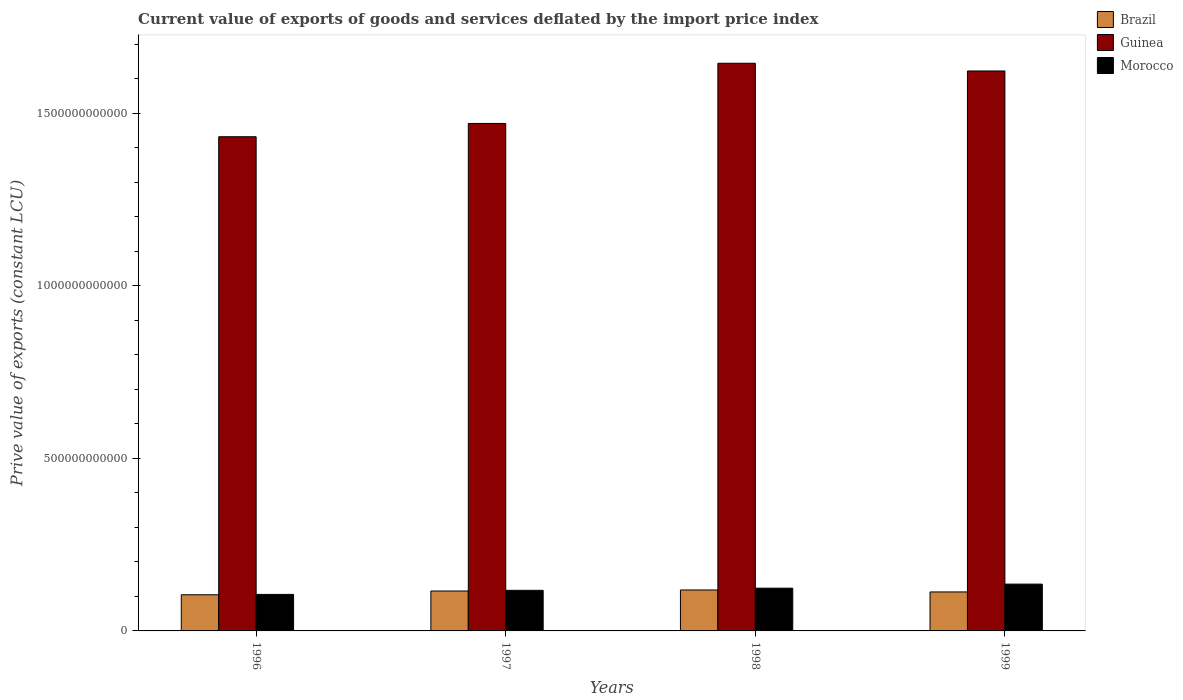How many different coloured bars are there?
Provide a succinct answer. 3. How many groups of bars are there?
Make the answer very short. 4. Are the number of bars per tick equal to the number of legend labels?
Provide a short and direct response. Yes. Are the number of bars on each tick of the X-axis equal?
Make the answer very short. Yes. How many bars are there on the 1st tick from the left?
Your answer should be compact. 3. How many bars are there on the 1st tick from the right?
Provide a short and direct response. 3. What is the prive value of exports in Brazil in 1998?
Your answer should be compact. 1.19e+11. Across all years, what is the maximum prive value of exports in Morocco?
Offer a terse response. 1.36e+11. Across all years, what is the minimum prive value of exports in Brazil?
Ensure brevity in your answer.  1.05e+11. In which year was the prive value of exports in Morocco maximum?
Make the answer very short. 1999. What is the total prive value of exports in Brazil in the graph?
Your response must be concise. 4.52e+11. What is the difference between the prive value of exports in Morocco in 1997 and that in 1999?
Keep it short and to the point. -1.80e+1. What is the difference between the prive value of exports in Morocco in 1998 and the prive value of exports in Brazil in 1999?
Your answer should be very brief. 1.09e+1. What is the average prive value of exports in Morocco per year?
Keep it short and to the point. 1.21e+11. In the year 1997, what is the difference between the prive value of exports in Guinea and prive value of exports in Morocco?
Keep it short and to the point. 1.35e+12. What is the ratio of the prive value of exports in Brazil in 1997 to that in 1999?
Offer a very short reply. 1.02. What is the difference between the highest and the second highest prive value of exports in Brazil?
Offer a terse response. 2.99e+09. What is the difference between the highest and the lowest prive value of exports in Brazil?
Your answer should be compact. 1.39e+1. In how many years, is the prive value of exports in Brazil greater than the average prive value of exports in Brazil taken over all years?
Provide a succinct answer. 2. What does the 3rd bar from the left in 1996 represents?
Offer a terse response. Morocco. What does the 1st bar from the right in 1997 represents?
Provide a succinct answer. Morocco. What is the difference between two consecutive major ticks on the Y-axis?
Provide a short and direct response. 5.00e+11. Are the values on the major ticks of Y-axis written in scientific E-notation?
Your answer should be very brief. No. Does the graph contain grids?
Offer a very short reply. No. Where does the legend appear in the graph?
Provide a succinct answer. Top right. What is the title of the graph?
Provide a short and direct response. Current value of exports of goods and services deflated by the import price index. What is the label or title of the Y-axis?
Your answer should be compact. Prive value of exports (constant LCU). What is the Prive value of exports (constant LCU) of Brazil in 1996?
Make the answer very short. 1.05e+11. What is the Prive value of exports (constant LCU) of Guinea in 1996?
Make the answer very short. 1.43e+12. What is the Prive value of exports (constant LCU) of Morocco in 1996?
Your answer should be compact. 1.06e+11. What is the Prive value of exports (constant LCU) of Brazil in 1997?
Offer a very short reply. 1.16e+11. What is the Prive value of exports (constant LCU) in Guinea in 1997?
Your response must be concise. 1.47e+12. What is the Prive value of exports (constant LCU) in Morocco in 1997?
Your response must be concise. 1.18e+11. What is the Prive value of exports (constant LCU) of Brazil in 1998?
Your answer should be compact. 1.19e+11. What is the Prive value of exports (constant LCU) of Guinea in 1998?
Offer a terse response. 1.64e+12. What is the Prive value of exports (constant LCU) of Morocco in 1998?
Your response must be concise. 1.24e+11. What is the Prive value of exports (constant LCU) in Brazil in 1999?
Offer a terse response. 1.13e+11. What is the Prive value of exports (constant LCU) of Guinea in 1999?
Offer a very short reply. 1.62e+12. What is the Prive value of exports (constant LCU) in Morocco in 1999?
Make the answer very short. 1.36e+11. Across all years, what is the maximum Prive value of exports (constant LCU) in Brazil?
Make the answer very short. 1.19e+11. Across all years, what is the maximum Prive value of exports (constant LCU) in Guinea?
Your answer should be very brief. 1.64e+12. Across all years, what is the maximum Prive value of exports (constant LCU) in Morocco?
Keep it short and to the point. 1.36e+11. Across all years, what is the minimum Prive value of exports (constant LCU) of Brazil?
Your response must be concise. 1.05e+11. Across all years, what is the minimum Prive value of exports (constant LCU) of Guinea?
Your answer should be compact. 1.43e+12. Across all years, what is the minimum Prive value of exports (constant LCU) of Morocco?
Your answer should be very brief. 1.06e+11. What is the total Prive value of exports (constant LCU) in Brazil in the graph?
Make the answer very short. 4.52e+11. What is the total Prive value of exports (constant LCU) of Guinea in the graph?
Provide a short and direct response. 6.17e+12. What is the total Prive value of exports (constant LCU) of Morocco in the graph?
Your response must be concise. 4.83e+11. What is the difference between the Prive value of exports (constant LCU) of Brazil in 1996 and that in 1997?
Your answer should be very brief. -1.09e+1. What is the difference between the Prive value of exports (constant LCU) of Guinea in 1996 and that in 1997?
Ensure brevity in your answer.  -3.85e+1. What is the difference between the Prive value of exports (constant LCU) of Morocco in 1996 and that in 1997?
Give a very brief answer. -1.18e+1. What is the difference between the Prive value of exports (constant LCU) of Brazil in 1996 and that in 1998?
Keep it short and to the point. -1.39e+1. What is the difference between the Prive value of exports (constant LCU) of Guinea in 1996 and that in 1998?
Your answer should be compact. -2.13e+11. What is the difference between the Prive value of exports (constant LCU) in Morocco in 1996 and that in 1998?
Your response must be concise. -1.80e+1. What is the difference between the Prive value of exports (constant LCU) of Brazil in 1996 and that in 1999?
Offer a terse response. -8.17e+09. What is the difference between the Prive value of exports (constant LCU) in Guinea in 1996 and that in 1999?
Provide a short and direct response. -1.91e+11. What is the difference between the Prive value of exports (constant LCU) in Morocco in 1996 and that in 1999?
Give a very brief answer. -2.98e+1. What is the difference between the Prive value of exports (constant LCU) of Brazil in 1997 and that in 1998?
Your response must be concise. -2.99e+09. What is the difference between the Prive value of exports (constant LCU) of Guinea in 1997 and that in 1998?
Give a very brief answer. -1.74e+11. What is the difference between the Prive value of exports (constant LCU) of Morocco in 1997 and that in 1998?
Give a very brief answer. -6.26e+09. What is the difference between the Prive value of exports (constant LCU) of Brazil in 1997 and that in 1999?
Offer a terse response. 2.72e+09. What is the difference between the Prive value of exports (constant LCU) in Guinea in 1997 and that in 1999?
Your response must be concise. -1.52e+11. What is the difference between the Prive value of exports (constant LCU) in Morocco in 1997 and that in 1999?
Ensure brevity in your answer.  -1.80e+1. What is the difference between the Prive value of exports (constant LCU) of Brazil in 1998 and that in 1999?
Provide a short and direct response. 5.71e+09. What is the difference between the Prive value of exports (constant LCU) of Guinea in 1998 and that in 1999?
Keep it short and to the point. 2.23e+1. What is the difference between the Prive value of exports (constant LCU) in Morocco in 1998 and that in 1999?
Ensure brevity in your answer.  -1.17e+1. What is the difference between the Prive value of exports (constant LCU) of Brazil in 1996 and the Prive value of exports (constant LCU) of Guinea in 1997?
Your answer should be compact. -1.37e+12. What is the difference between the Prive value of exports (constant LCU) of Brazil in 1996 and the Prive value of exports (constant LCU) of Morocco in 1997?
Your answer should be very brief. -1.28e+1. What is the difference between the Prive value of exports (constant LCU) of Guinea in 1996 and the Prive value of exports (constant LCU) of Morocco in 1997?
Your answer should be compact. 1.31e+12. What is the difference between the Prive value of exports (constant LCU) of Brazil in 1996 and the Prive value of exports (constant LCU) of Guinea in 1998?
Offer a very short reply. -1.54e+12. What is the difference between the Prive value of exports (constant LCU) of Brazil in 1996 and the Prive value of exports (constant LCU) of Morocco in 1998?
Your answer should be very brief. -1.91e+1. What is the difference between the Prive value of exports (constant LCU) of Guinea in 1996 and the Prive value of exports (constant LCU) of Morocco in 1998?
Provide a succinct answer. 1.31e+12. What is the difference between the Prive value of exports (constant LCU) in Brazil in 1996 and the Prive value of exports (constant LCU) in Guinea in 1999?
Give a very brief answer. -1.52e+12. What is the difference between the Prive value of exports (constant LCU) of Brazil in 1996 and the Prive value of exports (constant LCU) of Morocco in 1999?
Provide a succinct answer. -3.08e+1. What is the difference between the Prive value of exports (constant LCU) of Guinea in 1996 and the Prive value of exports (constant LCU) of Morocco in 1999?
Offer a terse response. 1.30e+12. What is the difference between the Prive value of exports (constant LCU) in Brazil in 1997 and the Prive value of exports (constant LCU) in Guinea in 1998?
Your response must be concise. -1.53e+12. What is the difference between the Prive value of exports (constant LCU) of Brazil in 1997 and the Prive value of exports (constant LCU) of Morocco in 1998?
Offer a terse response. -8.22e+09. What is the difference between the Prive value of exports (constant LCU) of Guinea in 1997 and the Prive value of exports (constant LCU) of Morocco in 1998?
Provide a short and direct response. 1.35e+12. What is the difference between the Prive value of exports (constant LCU) of Brazil in 1997 and the Prive value of exports (constant LCU) of Guinea in 1999?
Offer a very short reply. -1.51e+12. What is the difference between the Prive value of exports (constant LCU) of Brazil in 1997 and the Prive value of exports (constant LCU) of Morocco in 1999?
Give a very brief answer. -2.00e+1. What is the difference between the Prive value of exports (constant LCU) of Guinea in 1997 and the Prive value of exports (constant LCU) of Morocco in 1999?
Your answer should be very brief. 1.33e+12. What is the difference between the Prive value of exports (constant LCU) in Brazil in 1998 and the Prive value of exports (constant LCU) in Guinea in 1999?
Your answer should be very brief. -1.50e+12. What is the difference between the Prive value of exports (constant LCU) in Brazil in 1998 and the Prive value of exports (constant LCU) in Morocco in 1999?
Give a very brief answer. -1.70e+1. What is the difference between the Prive value of exports (constant LCU) in Guinea in 1998 and the Prive value of exports (constant LCU) in Morocco in 1999?
Give a very brief answer. 1.51e+12. What is the average Prive value of exports (constant LCU) in Brazil per year?
Offer a terse response. 1.13e+11. What is the average Prive value of exports (constant LCU) of Guinea per year?
Provide a succinct answer. 1.54e+12. What is the average Prive value of exports (constant LCU) of Morocco per year?
Ensure brevity in your answer.  1.21e+11. In the year 1996, what is the difference between the Prive value of exports (constant LCU) of Brazil and Prive value of exports (constant LCU) of Guinea?
Provide a short and direct response. -1.33e+12. In the year 1996, what is the difference between the Prive value of exports (constant LCU) of Brazil and Prive value of exports (constant LCU) of Morocco?
Keep it short and to the point. -1.06e+09. In the year 1996, what is the difference between the Prive value of exports (constant LCU) of Guinea and Prive value of exports (constant LCU) of Morocco?
Offer a terse response. 1.33e+12. In the year 1997, what is the difference between the Prive value of exports (constant LCU) in Brazil and Prive value of exports (constant LCU) in Guinea?
Your answer should be very brief. -1.35e+12. In the year 1997, what is the difference between the Prive value of exports (constant LCU) of Brazil and Prive value of exports (constant LCU) of Morocco?
Provide a succinct answer. -1.96e+09. In the year 1997, what is the difference between the Prive value of exports (constant LCU) of Guinea and Prive value of exports (constant LCU) of Morocco?
Your response must be concise. 1.35e+12. In the year 1998, what is the difference between the Prive value of exports (constant LCU) in Brazil and Prive value of exports (constant LCU) in Guinea?
Ensure brevity in your answer.  -1.53e+12. In the year 1998, what is the difference between the Prive value of exports (constant LCU) of Brazil and Prive value of exports (constant LCU) of Morocco?
Offer a very short reply. -5.23e+09. In the year 1998, what is the difference between the Prive value of exports (constant LCU) of Guinea and Prive value of exports (constant LCU) of Morocco?
Give a very brief answer. 1.52e+12. In the year 1999, what is the difference between the Prive value of exports (constant LCU) of Brazil and Prive value of exports (constant LCU) of Guinea?
Offer a terse response. -1.51e+12. In the year 1999, what is the difference between the Prive value of exports (constant LCU) in Brazil and Prive value of exports (constant LCU) in Morocco?
Provide a short and direct response. -2.27e+1. In the year 1999, what is the difference between the Prive value of exports (constant LCU) of Guinea and Prive value of exports (constant LCU) of Morocco?
Make the answer very short. 1.49e+12. What is the ratio of the Prive value of exports (constant LCU) of Brazil in 1996 to that in 1997?
Make the answer very short. 0.91. What is the ratio of the Prive value of exports (constant LCU) of Guinea in 1996 to that in 1997?
Provide a short and direct response. 0.97. What is the ratio of the Prive value of exports (constant LCU) of Morocco in 1996 to that in 1997?
Offer a terse response. 0.9. What is the ratio of the Prive value of exports (constant LCU) in Brazil in 1996 to that in 1998?
Keep it short and to the point. 0.88. What is the ratio of the Prive value of exports (constant LCU) in Guinea in 1996 to that in 1998?
Your response must be concise. 0.87. What is the ratio of the Prive value of exports (constant LCU) of Morocco in 1996 to that in 1998?
Your response must be concise. 0.85. What is the ratio of the Prive value of exports (constant LCU) in Brazil in 1996 to that in 1999?
Give a very brief answer. 0.93. What is the ratio of the Prive value of exports (constant LCU) of Guinea in 1996 to that in 1999?
Make the answer very short. 0.88. What is the ratio of the Prive value of exports (constant LCU) in Morocco in 1996 to that in 1999?
Your response must be concise. 0.78. What is the ratio of the Prive value of exports (constant LCU) in Brazil in 1997 to that in 1998?
Offer a terse response. 0.97. What is the ratio of the Prive value of exports (constant LCU) in Guinea in 1997 to that in 1998?
Provide a short and direct response. 0.89. What is the ratio of the Prive value of exports (constant LCU) in Morocco in 1997 to that in 1998?
Keep it short and to the point. 0.95. What is the ratio of the Prive value of exports (constant LCU) in Brazil in 1997 to that in 1999?
Offer a very short reply. 1.02. What is the ratio of the Prive value of exports (constant LCU) in Guinea in 1997 to that in 1999?
Keep it short and to the point. 0.91. What is the ratio of the Prive value of exports (constant LCU) in Morocco in 1997 to that in 1999?
Offer a terse response. 0.87. What is the ratio of the Prive value of exports (constant LCU) in Brazil in 1998 to that in 1999?
Your answer should be very brief. 1.05. What is the ratio of the Prive value of exports (constant LCU) in Guinea in 1998 to that in 1999?
Keep it short and to the point. 1.01. What is the ratio of the Prive value of exports (constant LCU) of Morocco in 1998 to that in 1999?
Your answer should be compact. 0.91. What is the difference between the highest and the second highest Prive value of exports (constant LCU) in Brazil?
Keep it short and to the point. 2.99e+09. What is the difference between the highest and the second highest Prive value of exports (constant LCU) of Guinea?
Provide a succinct answer. 2.23e+1. What is the difference between the highest and the second highest Prive value of exports (constant LCU) in Morocco?
Your answer should be compact. 1.17e+1. What is the difference between the highest and the lowest Prive value of exports (constant LCU) of Brazil?
Provide a succinct answer. 1.39e+1. What is the difference between the highest and the lowest Prive value of exports (constant LCU) of Guinea?
Offer a very short reply. 2.13e+11. What is the difference between the highest and the lowest Prive value of exports (constant LCU) of Morocco?
Provide a short and direct response. 2.98e+1. 